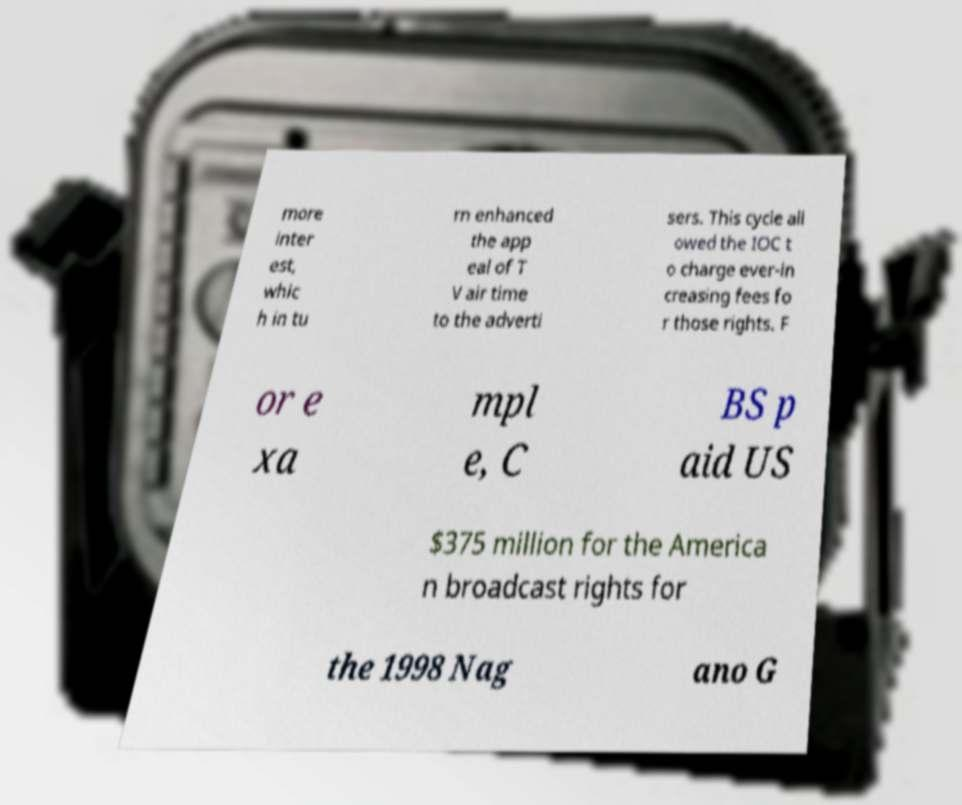Could you extract and type out the text from this image? more inter est, whic h in tu rn enhanced the app eal of T V air time to the adverti sers. This cycle all owed the IOC t o charge ever-in creasing fees fo r those rights. F or e xa mpl e, C BS p aid US $375 million for the America n broadcast rights for the 1998 Nag ano G 